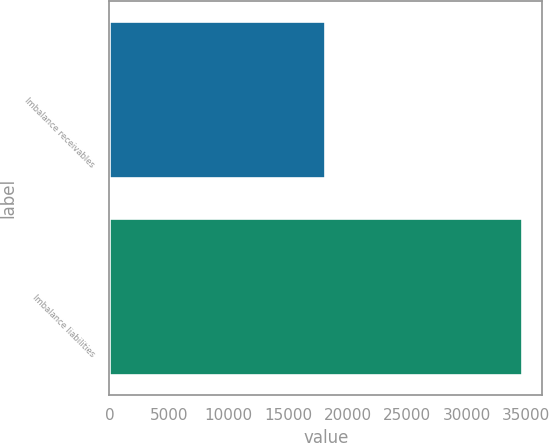Convert chart. <chart><loc_0><loc_0><loc_500><loc_500><bar_chart><fcel>Imbalance receivables<fcel>Imbalance liabilities<nl><fcel>18100<fcel>34600<nl></chart> 